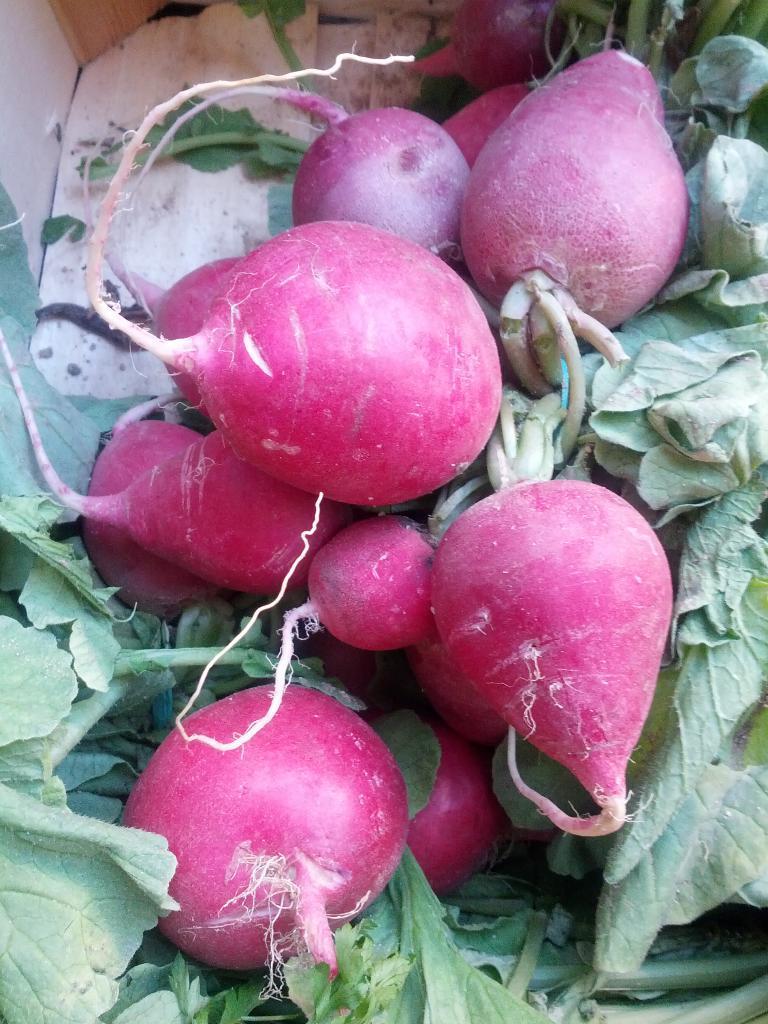In one or two sentences, can you explain what this image depicts? In this image these are a few turnip root vegetables and leaves. 